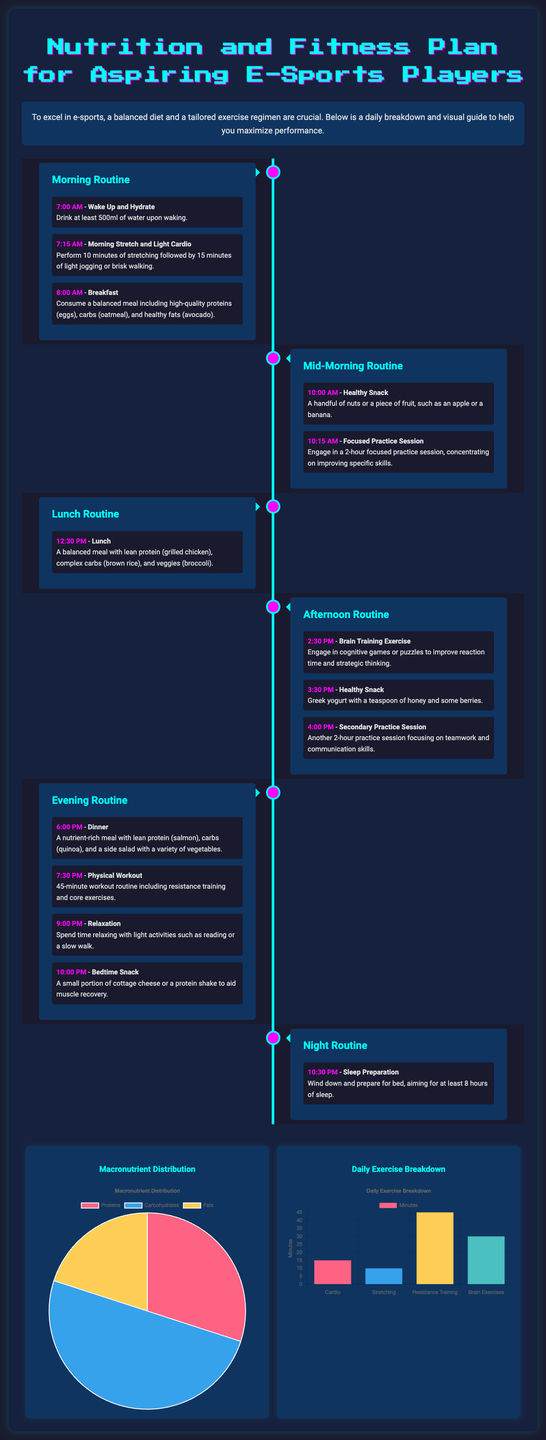What time does the morning routine start? The morning routine starts at 7:00 AM, as indicated in the document.
Answer: 7:00 AM What snack is recommended for mid-morning? The recommended mid-morning snack is a handful of nuts or a piece of fruit, such as an apple or a banana.
Answer: Nuts or fruit How many minutes are allocated for physical workouts in the evening? The evening routine includes a 45-minute workout routine, as detailed in the document.
Answer: 45 minutes What percentage of the diet should come from carbohydrates? According to the macronutrient distribution chart, carbohydrates should make up 50% of the diet.
Answer: 50% What activity is performed at 2:30 PM? At 2:30 PM, the activity is a brain training exercise.
Answer: Brain training exercise How long is the focused practice session in the mid-morning? The focused practice session in the mid-morning lasts for 2 hours.
Answer: 2 hours What type of meal is suggested for lunch? The lunch suggested should be a balanced meal with lean protein, complex carbs, and veggies.
Answer: Balanced meal What is the last activity before bedtime? The last activity before bedtime is sleep preparation, scheduled for 10:30 PM.
Answer: Sleep preparation What chart displays macronutrient distribution? The pie chart displays macronutrient distribution in the document.
Answer: Macronutrient Distribution Chart 